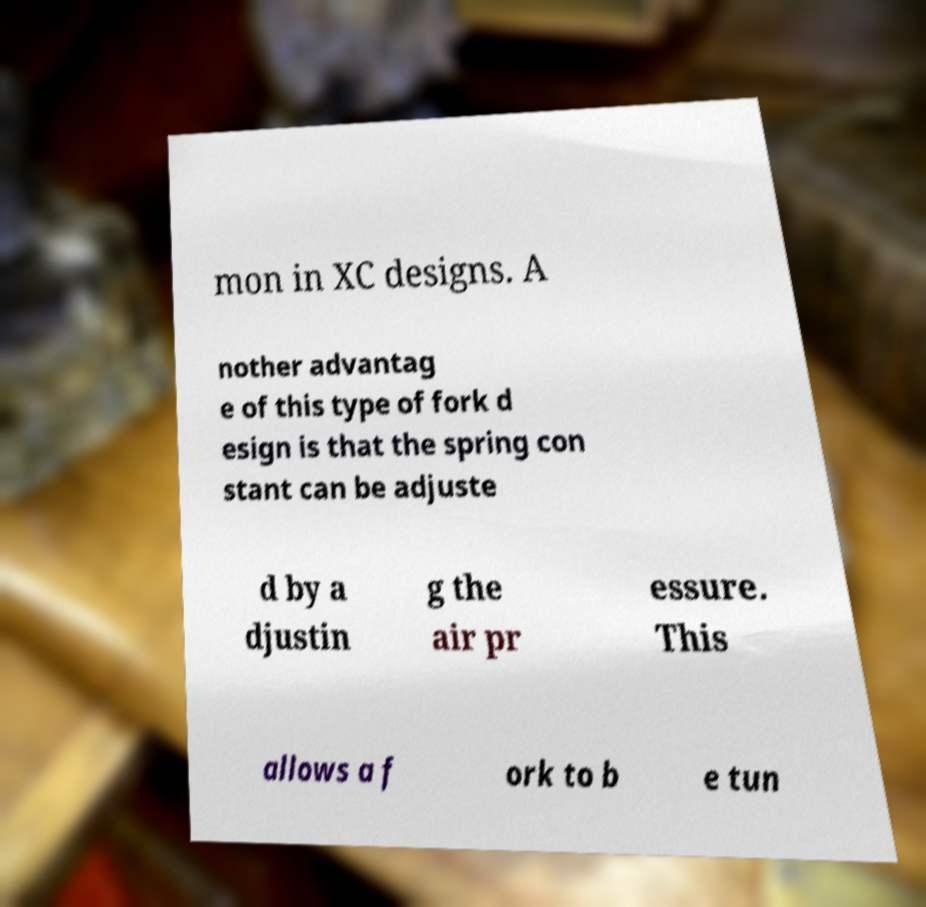I need the written content from this picture converted into text. Can you do that? mon in XC designs. A nother advantag e of this type of fork d esign is that the spring con stant can be adjuste d by a djustin g the air pr essure. This allows a f ork to b e tun 